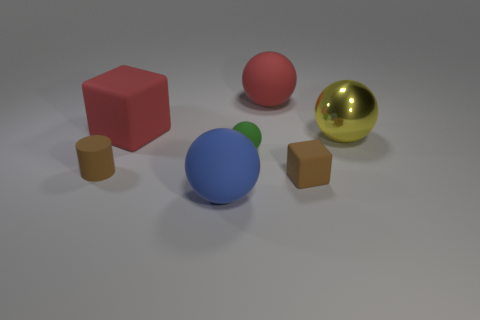There is a small cylinder that is on the left side of the green thing; what is its material?
Your response must be concise. Rubber. What size is the matte cube that is to the left of the big sphere left of the rubber sphere behind the yellow thing?
Your answer should be compact. Large. There is a brown cylinder; does it have the same size as the matte block that is on the right side of the large blue matte object?
Your answer should be compact. Yes. There is a rubber sphere that is behind the yellow metal thing; what color is it?
Make the answer very short. Red. There is a thing that is the same color as the cylinder; what is its shape?
Your answer should be very brief. Cube. What is the shape of the large rubber object to the right of the green thing?
Provide a succinct answer. Sphere. How many gray things are small spheres or blocks?
Keep it short and to the point. 0. Is the material of the blue sphere the same as the tiny cube?
Offer a terse response. Yes. How many tiny matte things are to the left of the blue matte thing?
Your answer should be compact. 1. What material is the thing that is left of the big red matte ball and behind the yellow sphere?
Give a very brief answer. Rubber. 